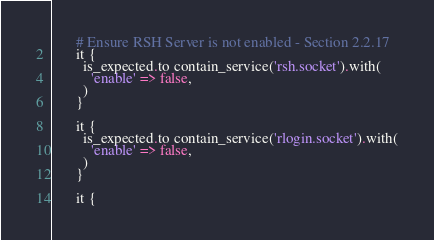<code> <loc_0><loc_0><loc_500><loc_500><_Ruby_>
      # Ensure RSH Server is not enabled - Section 2.2.17
      it {
        is_expected.to contain_service('rsh.socket').with(
          'enable' => false,
        )
      }

      it {
        is_expected.to contain_service('rlogin.socket').with(
          'enable' => false,
        )
      }

      it {</code> 